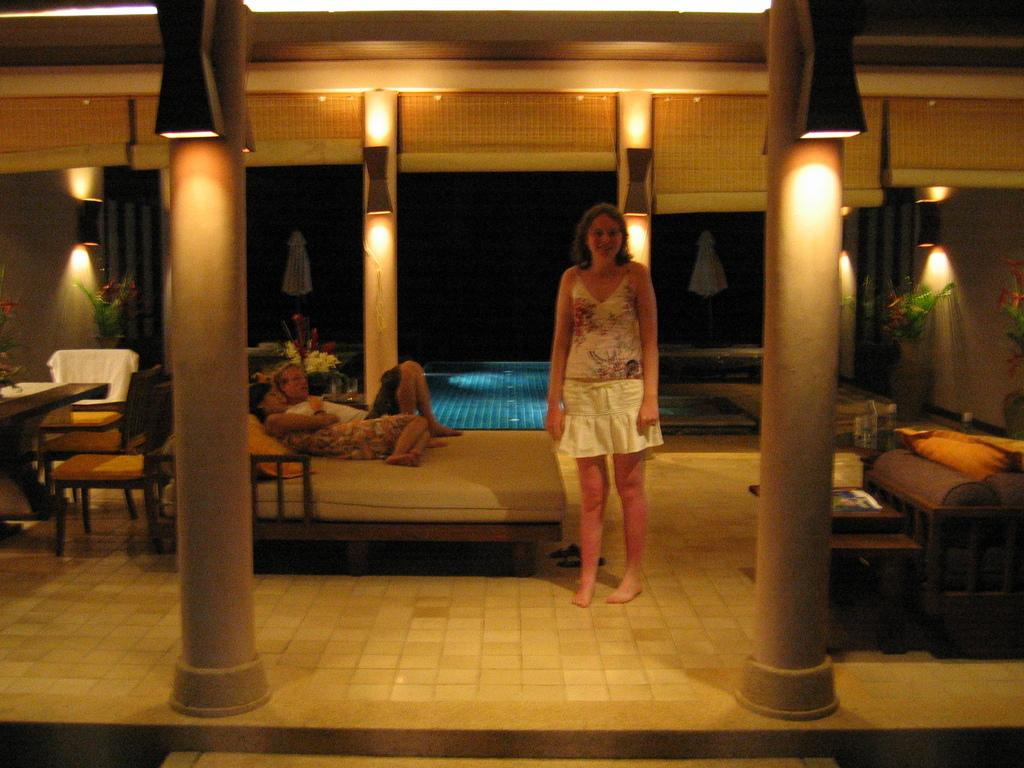What is the primary subject of the image? There is a woman standing in the image. Can you describe the other people in the image? The other people are lying on a bed in the image. How many boats are visible in the image? There are no boats present in the image. What type of writing instrument is the woman holding in the image? The woman is not holding a quill or any writing instrument in the image. 